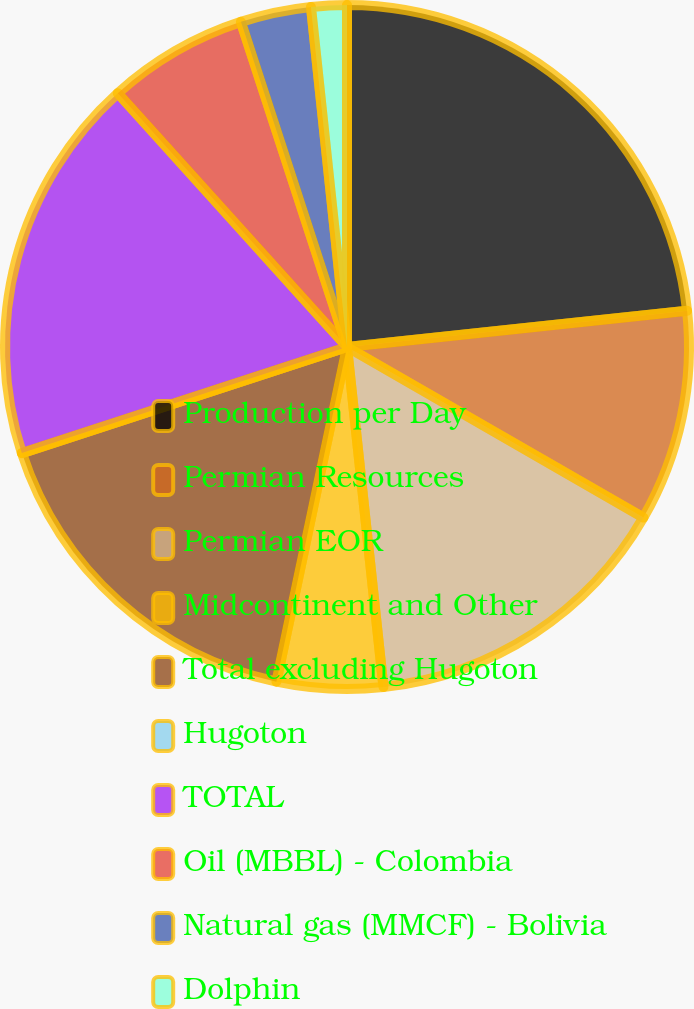<chart> <loc_0><loc_0><loc_500><loc_500><pie_chart><fcel>Production per Day<fcel>Permian Resources<fcel>Permian EOR<fcel>Midcontinent and Other<fcel>Total excluding Hugoton<fcel>Hugoton<fcel>TOTAL<fcel>Oil (MBBL) - Colombia<fcel>Natural gas (MMCF) - Bolivia<fcel>Dolphin<nl><fcel>23.31%<fcel>10.0%<fcel>14.99%<fcel>5.01%<fcel>16.66%<fcel>0.02%<fcel>18.32%<fcel>6.67%<fcel>3.34%<fcel>1.68%<nl></chart> 